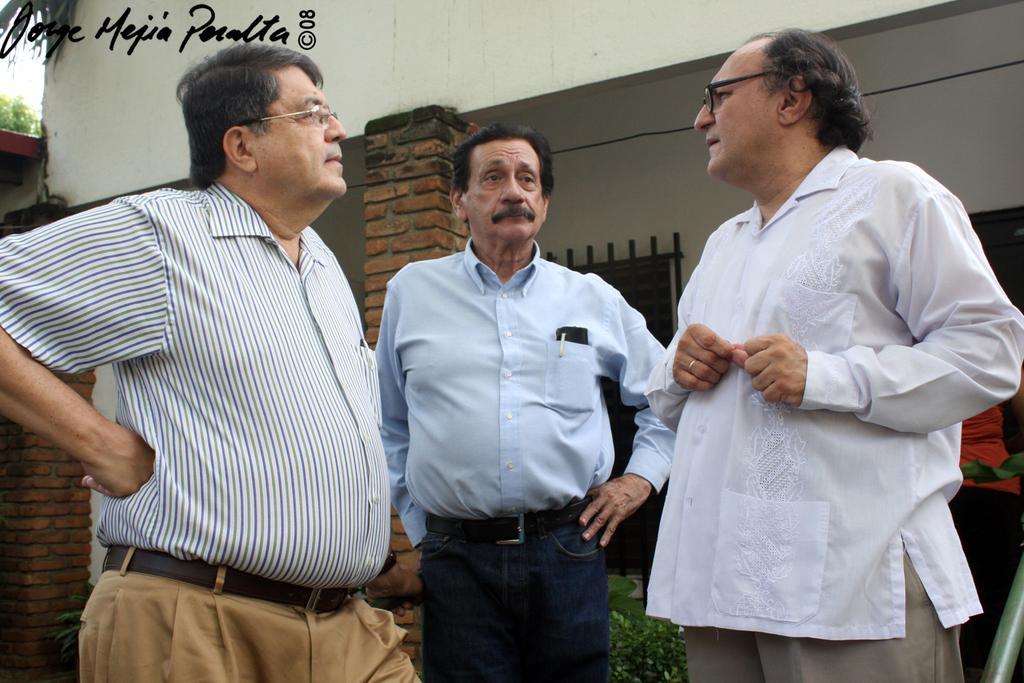How would you summarize this image in a sentence or two? There are people standing. In the background we can see pillars, plants, windows, person, rod, wire and wall. In the top left side of the image we can see text. 